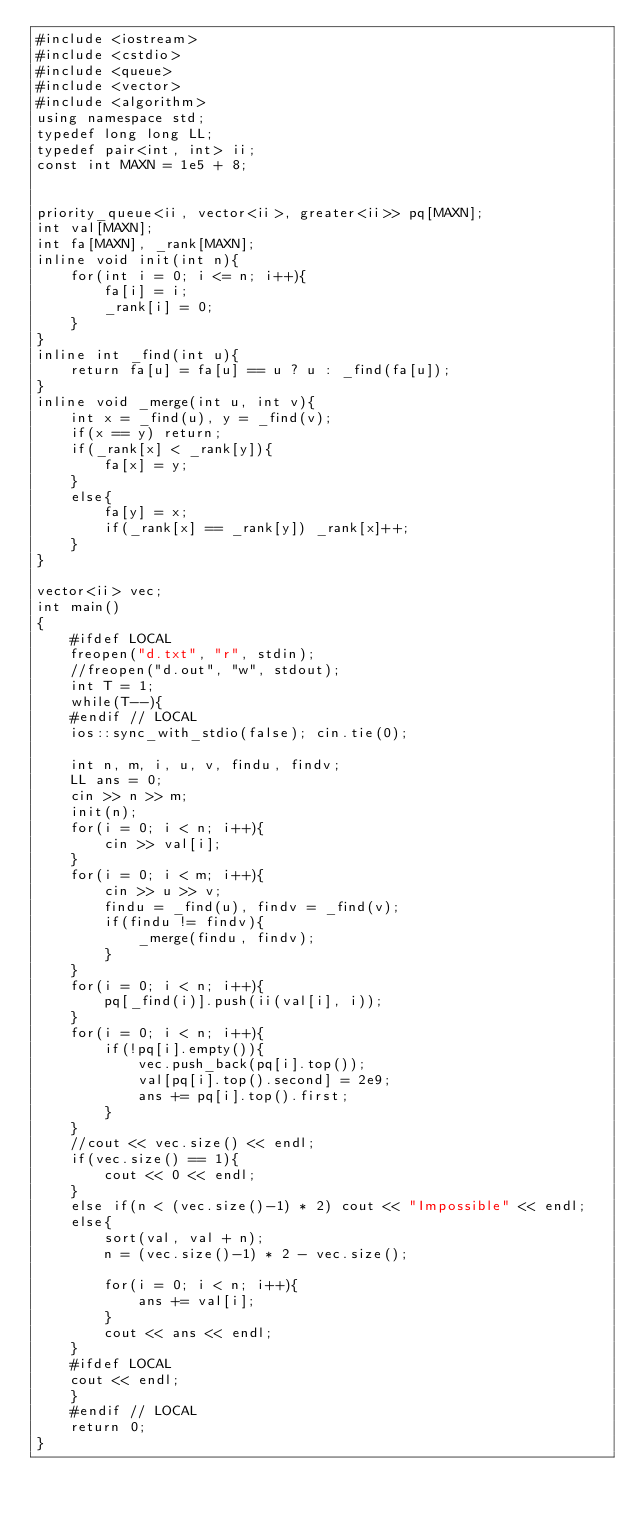<code> <loc_0><loc_0><loc_500><loc_500><_C++_>#include <iostream>
#include <cstdio>
#include <queue>
#include <vector>
#include <algorithm>
using namespace std;
typedef long long LL;
typedef pair<int, int> ii;
const int MAXN = 1e5 + 8;
 
 
priority_queue<ii, vector<ii>, greater<ii>> pq[MAXN];
int val[MAXN];
int fa[MAXN], _rank[MAXN];
inline void init(int n){
    for(int i = 0; i <= n; i++){
        fa[i] = i;
        _rank[i] = 0;
    }
}
inline int _find(int u){
    return fa[u] = fa[u] == u ? u : _find(fa[u]);
}
inline void _merge(int u, int v){
    int x = _find(u), y = _find(v);
    if(x == y) return;
    if(_rank[x] < _rank[y]){
        fa[x] = y;
    }
    else{
        fa[y] = x;
        if(_rank[x] == _rank[y]) _rank[x]++;
    }
}
 
vector<ii> vec;
int main()
{
    #ifdef LOCAL
    freopen("d.txt", "r", stdin);
    //freopen("d.out", "w", stdout);
    int T = 1;
    while(T--){
    #endif // LOCAL
    ios::sync_with_stdio(false); cin.tie(0);
 
    int n, m, i, u, v, findu, findv;
    LL ans = 0;
    cin >> n >> m;
    init(n);
    for(i = 0; i < n; i++){
        cin >> val[i];
    }
    for(i = 0; i < m; i++){
        cin >> u >> v;
        findu = _find(u), findv = _find(v);
        if(findu != findv){
            _merge(findu, findv);
        }
    }
    for(i = 0; i < n; i++){
        pq[_find(i)].push(ii(val[i], i));
    }
    for(i = 0; i < n; i++){
        if(!pq[i].empty()){
            vec.push_back(pq[i].top());
            val[pq[i].top().second] = 2e9;
            ans += pq[i].top().first;
        }
    }
    //cout << vec.size() << endl;
    if(vec.size() == 1){
        cout << 0 << endl;
    }
    else if(n < (vec.size()-1) * 2) cout << "Impossible" << endl;
    else{
        sort(val, val + n);
        n = (vec.size()-1) * 2 - vec.size();
 
        for(i = 0; i < n; i++){
            ans += val[i];
        }
        cout << ans << endl;
    }
    #ifdef LOCAL
    cout << endl;
    }
    #endif // LOCAL
    return 0;
}</code> 